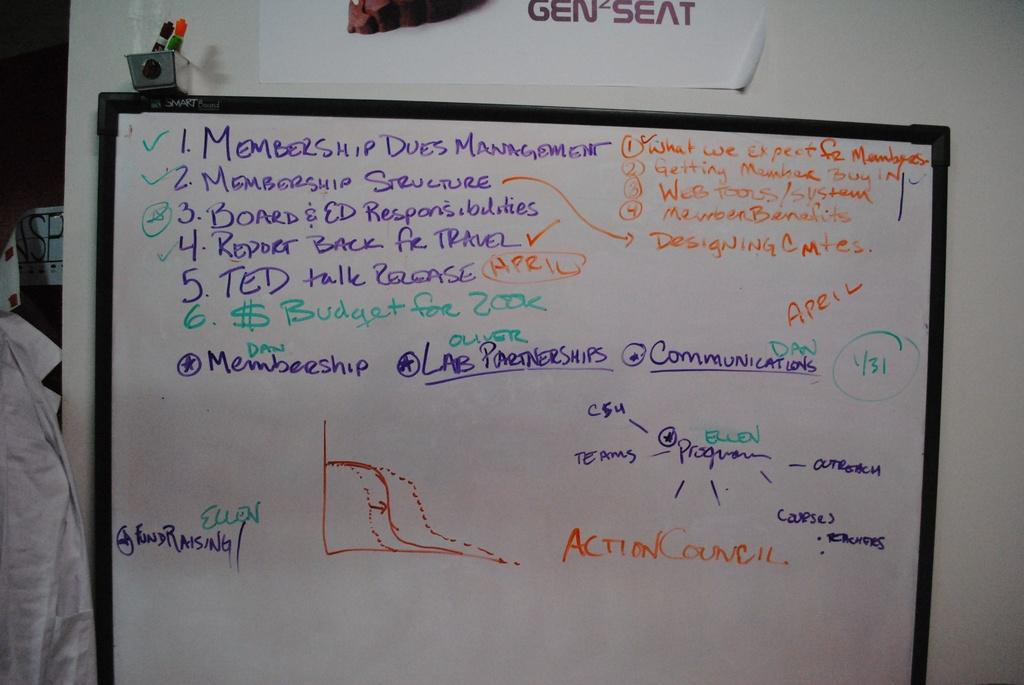<image>
Describe the image concisely. The number one item on a list on the board says "membership dues management." 